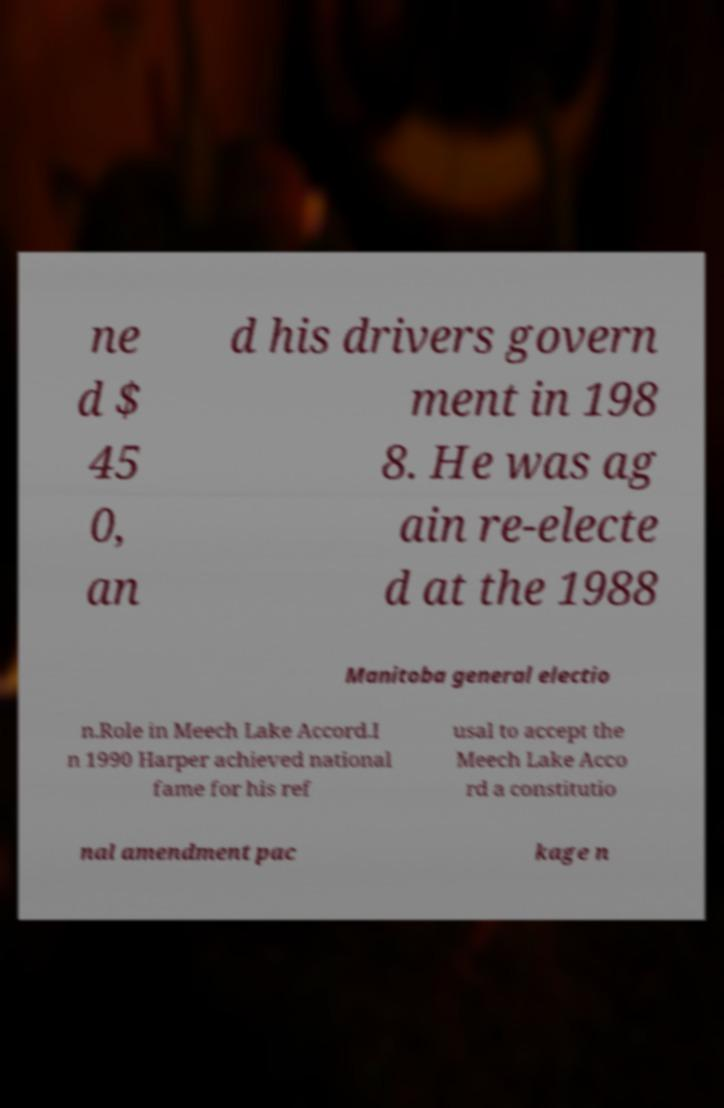For documentation purposes, I need the text within this image transcribed. Could you provide that? ne d $ 45 0, an d his drivers govern ment in 198 8. He was ag ain re-electe d at the 1988 Manitoba general electio n.Role in Meech Lake Accord.I n 1990 Harper achieved national fame for his ref usal to accept the Meech Lake Acco rd a constitutio nal amendment pac kage n 